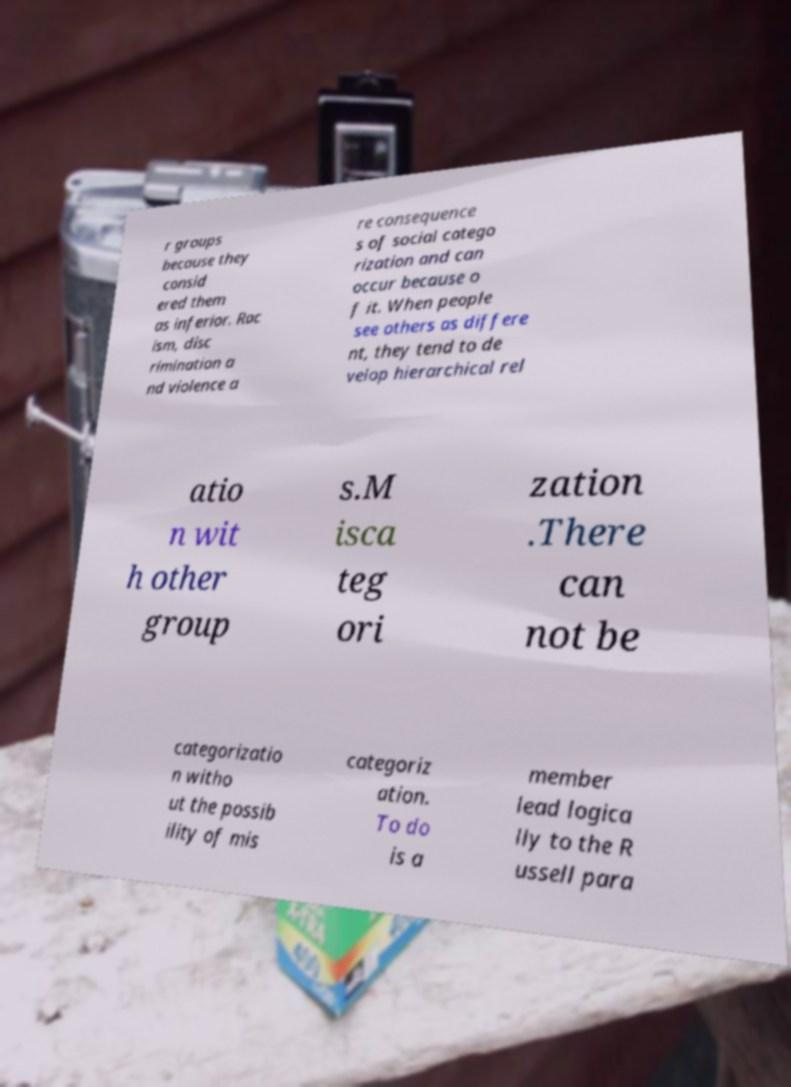For documentation purposes, I need the text within this image transcribed. Could you provide that? r groups because they consid ered them as inferior. Rac ism, disc rimination a nd violence a re consequence s of social catego rization and can occur because o f it. When people see others as differe nt, they tend to de velop hierarchical rel atio n wit h other group s.M isca teg ori zation .There can not be categorizatio n witho ut the possib ility of mis categoriz ation. To do is a member lead logica lly to the R ussell para 